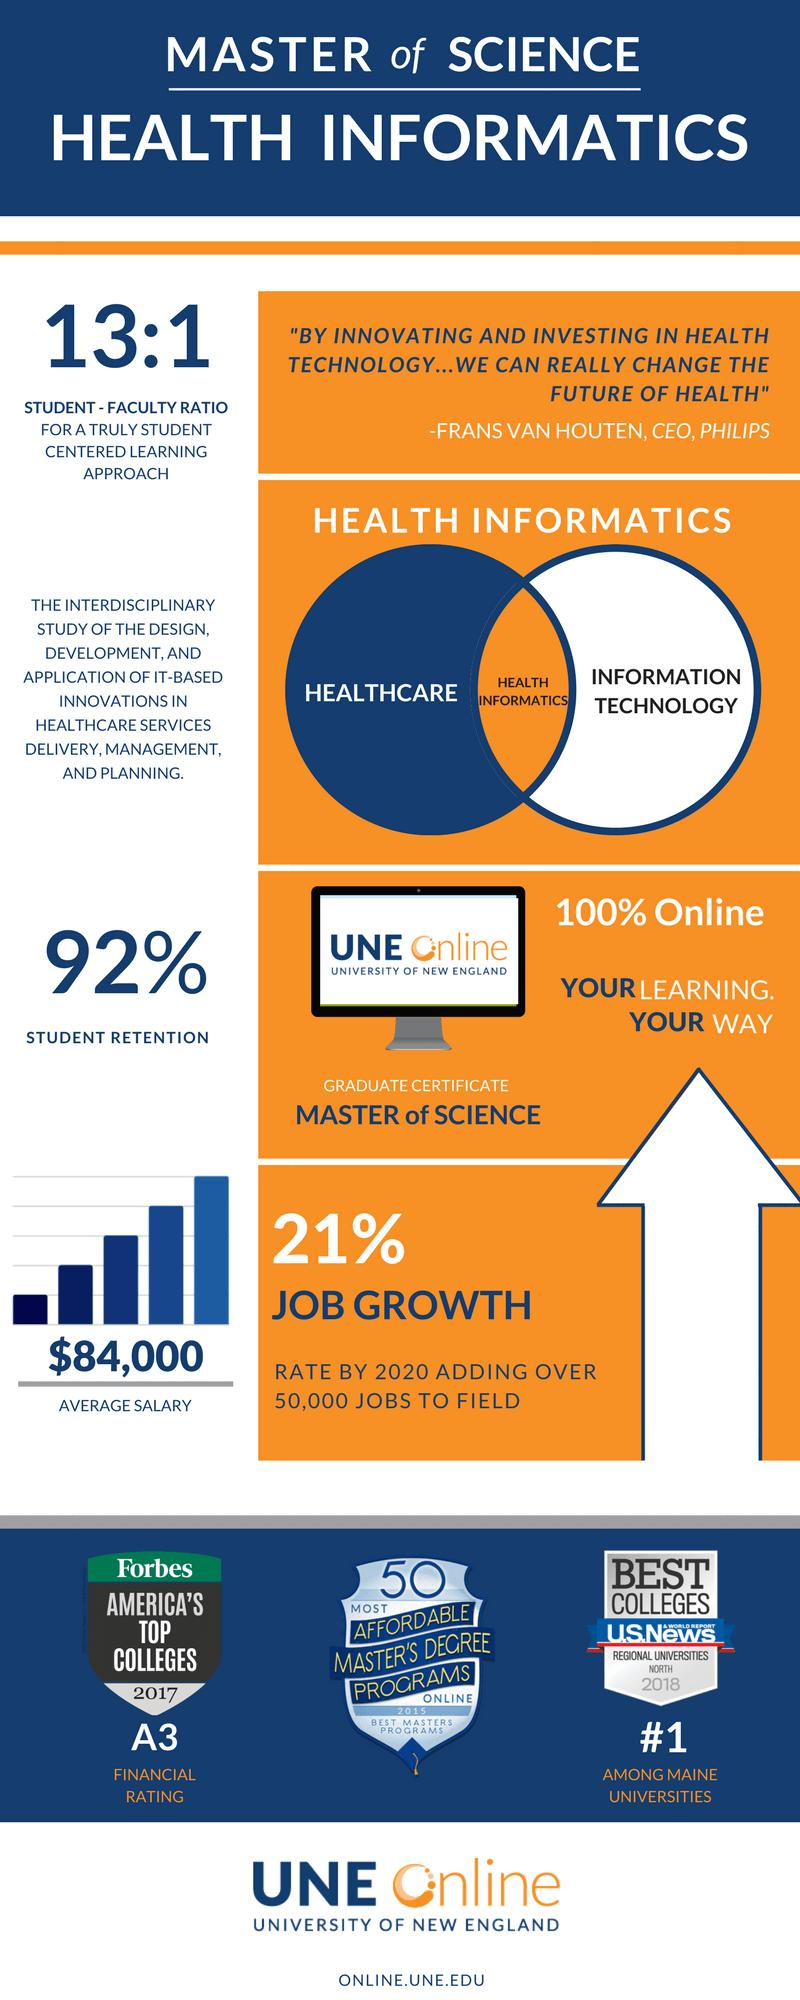Point out several critical features in this image. Health Informatics is a multidisciplinary field that encompasses various factors, including healthcare and information technology. 